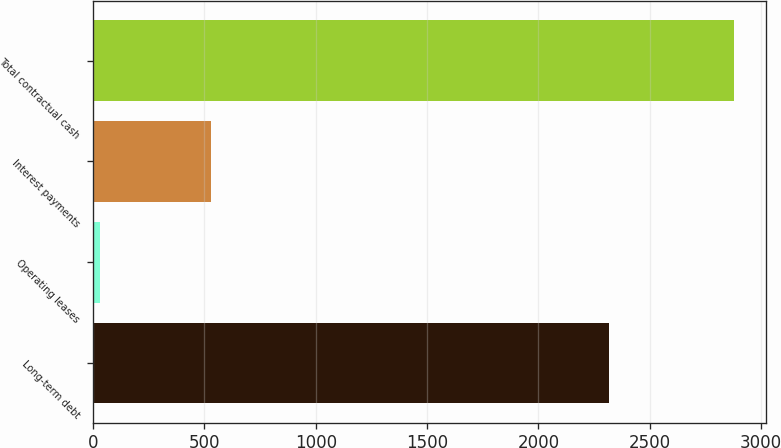Convert chart. <chart><loc_0><loc_0><loc_500><loc_500><bar_chart><fcel>Long-term debt<fcel>Operating leases<fcel>Interest payments<fcel>Total contractual cash<nl><fcel>2317<fcel>33.7<fcel>528.6<fcel>2879.3<nl></chart> 